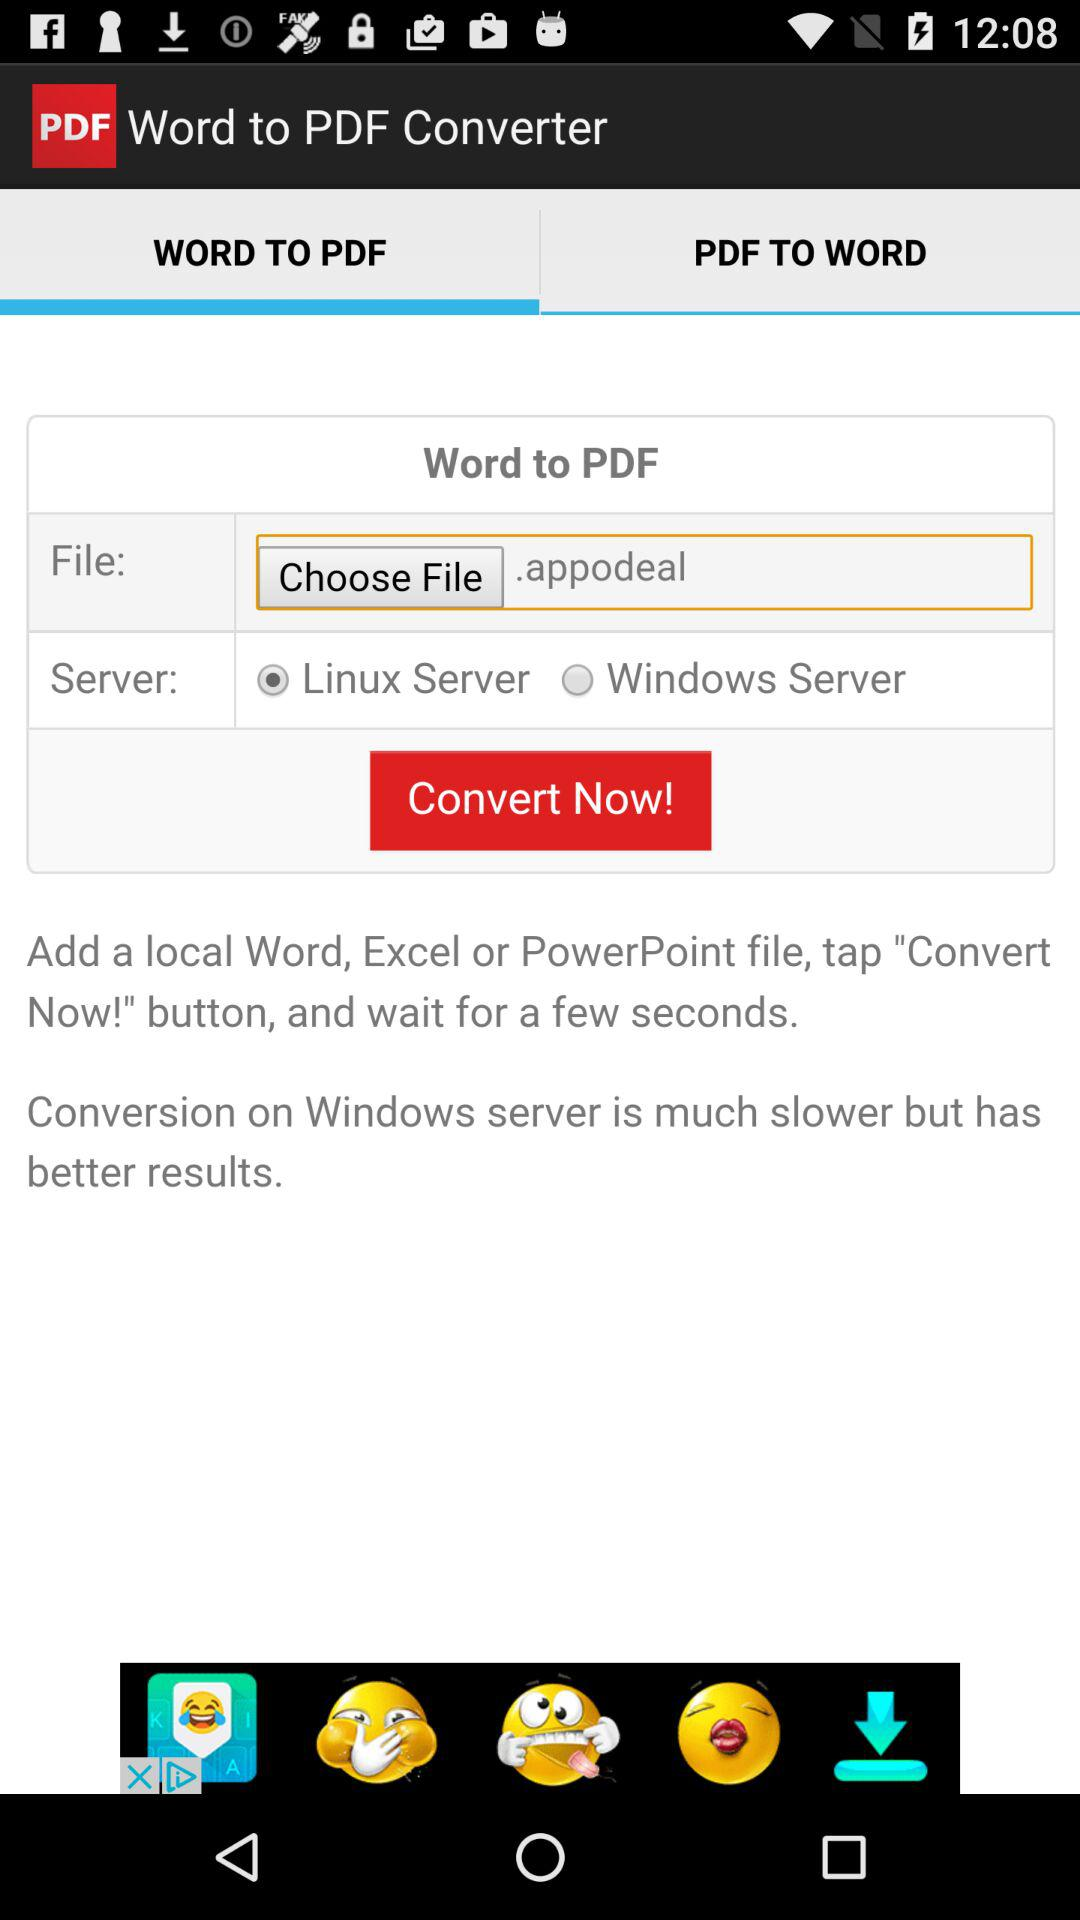How many file types can be converted?
Answer the question using a single word or phrase. 3 